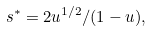Convert formula to latex. <formula><loc_0><loc_0><loc_500><loc_500>s ^ { * } = 2 u ^ { 1 / 2 } / ( 1 - u ) ,</formula> 